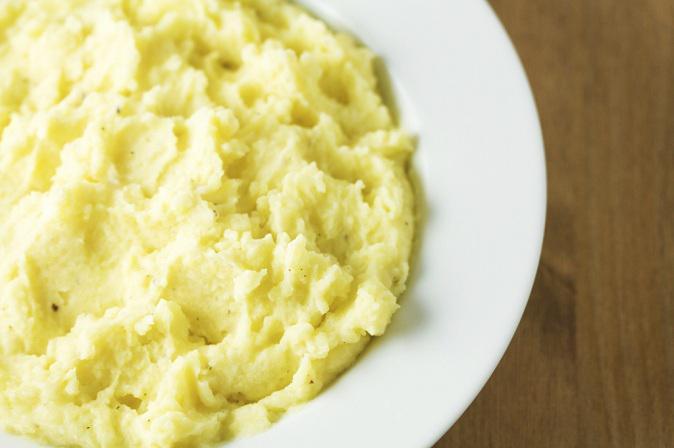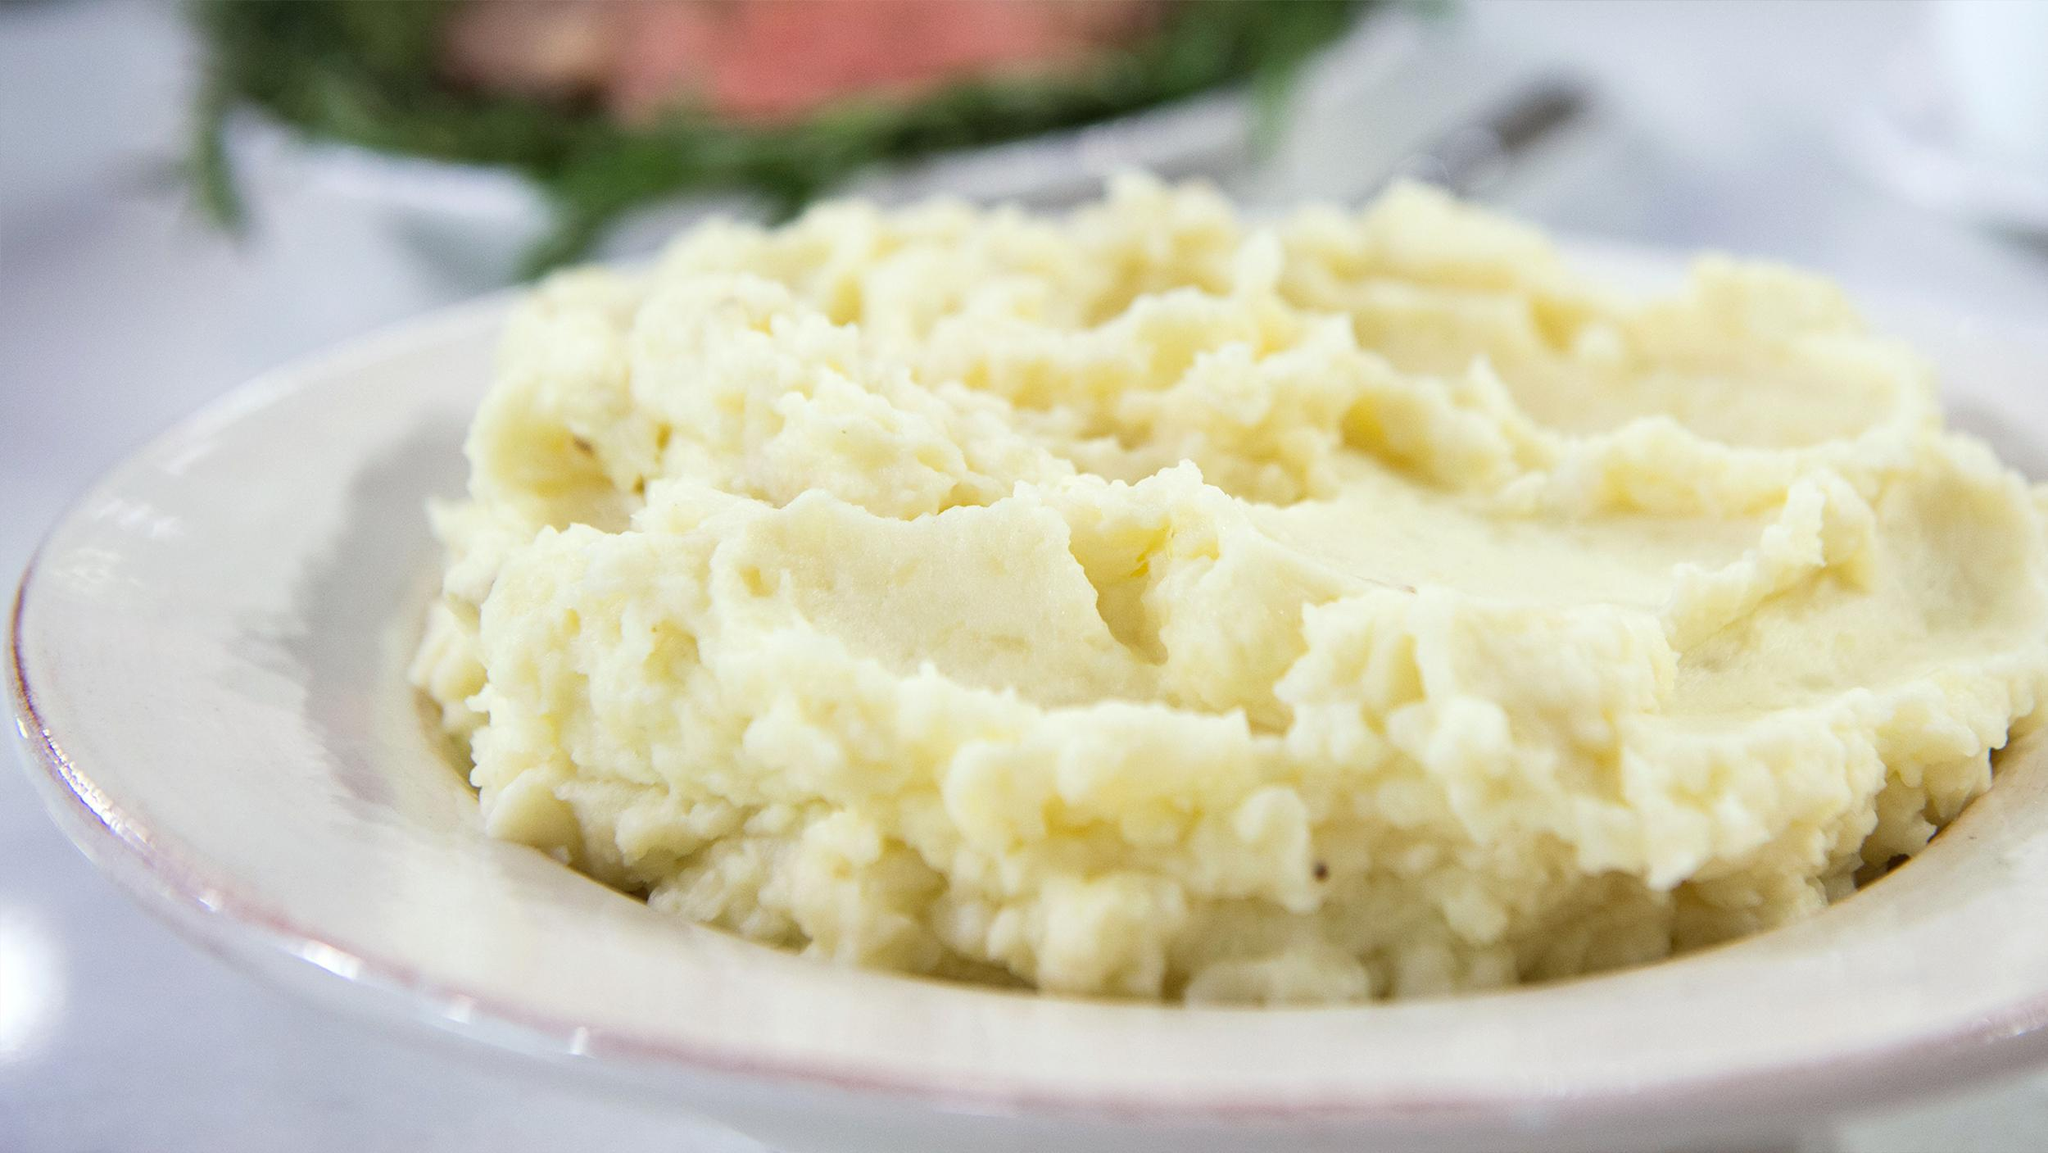The first image is the image on the left, the second image is the image on the right. For the images displayed, is the sentence "Each image shows mashed potatoes served - without gravy or other menu items - in a round white bowl." factually correct? Answer yes or no. Yes. 